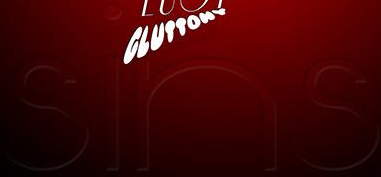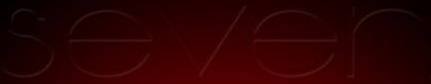What words can you see in these images in sequence, separated by a semicolon? sins; sever 